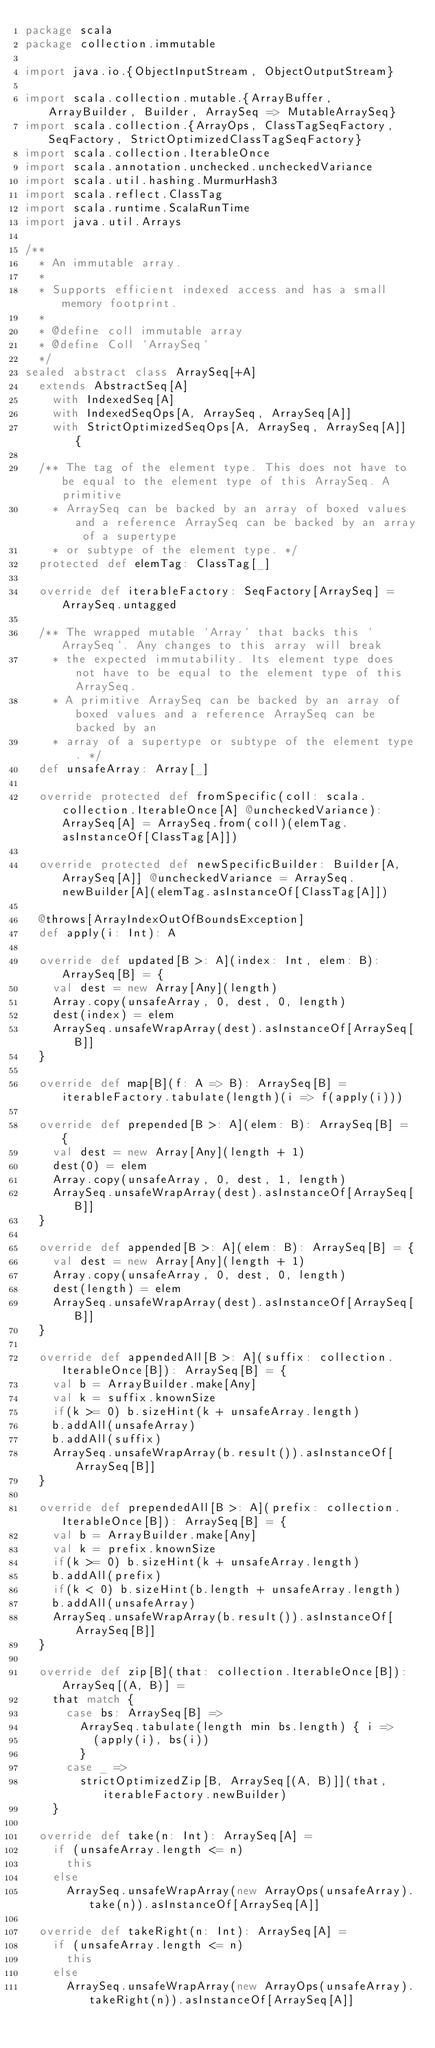Convert code to text. <code><loc_0><loc_0><loc_500><loc_500><_Scala_>package scala
package collection.immutable

import java.io.{ObjectInputStream, ObjectOutputStream}

import scala.collection.mutable.{ArrayBuffer, ArrayBuilder, Builder, ArraySeq => MutableArraySeq}
import scala.collection.{ArrayOps, ClassTagSeqFactory, SeqFactory, StrictOptimizedClassTagSeqFactory}
import scala.collection.IterableOnce
import scala.annotation.unchecked.uncheckedVariance
import scala.util.hashing.MurmurHash3
import scala.reflect.ClassTag
import scala.runtime.ScalaRunTime
import java.util.Arrays

/**
  * An immutable array.
  *
  * Supports efficient indexed access and has a small memory footprint.
  *
  * @define coll immutable array
  * @define Coll `ArraySeq`
  */
sealed abstract class ArraySeq[+A]
  extends AbstractSeq[A]
    with IndexedSeq[A]
    with IndexedSeqOps[A, ArraySeq, ArraySeq[A]]
    with StrictOptimizedSeqOps[A, ArraySeq, ArraySeq[A]] {

  /** The tag of the element type. This does not have to be equal to the element type of this ArraySeq. A primitive
    * ArraySeq can be backed by an array of boxed values and a reference ArraySeq can be backed by an array of a supertype
    * or subtype of the element type. */
  protected def elemTag: ClassTag[_]

  override def iterableFactory: SeqFactory[ArraySeq] = ArraySeq.untagged

  /** The wrapped mutable `Array` that backs this `ArraySeq`. Any changes to this array will break
    * the expected immutability. Its element type does not have to be equal to the element type of this ArraySeq.
    * A primitive ArraySeq can be backed by an array of boxed values and a reference ArraySeq can be backed by an
    * array of a supertype or subtype of the element type. */
  def unsafeArray: Array[_]

  override protected def fromSpecific(coll: scala.collection.IterableOnce[A] @uncheckedVariance): ArraySeq[A] = ArraySeq.from(coll)(elemTag.asInstanceOf[ClassTag[A]])

  override protected def newSpecificBuilder: Builder[A, ArraySeq[A]] @uncheckedVariance = ArraySeq.newBuilder[A](elemTag.asInstanceOf[ClassTag[A]])

  @throws[ArrayIndexOutOfBoundsException]
  def apply(i: Int): A

  override def updated[B >: A](index: Int, elem: B): ArraySeq[B] = {
    val dest = new Array[Any](length)
    Array.copy(unsafeArray, 0, dest, 0, length)
    dest(index) = elem
    ArraySeq.unsafeWrapArray(dest).asInstanceOf[ArraySeq[B]]
  }

  override def map[B](f: A => B): ArraySeq[B] = iterableFactory.tabulate(length)(i => f(apply(i)))

  override def prepended[B >: A](elem: B): ArraySeq[B] = {
    val dest = new Array[Any](length + 1)
    dest(0) = elem
    Array.copy(unsafeArray, 0, dest, 1, length)
    ArraySeq.unsafeWrapArray(dest).asInstanceOf[ArraySeq[B]]
  }

  override def appended[B >: A](elem: B): ArraySeq[B] = {
    val dest = new Array[Any](length + 1)
    Array.copy(unsafeArray, 0, dest, 0, length)
    dest(length) = elem
    ArraySeq.unsafeWrapArray(dest).asInstanceOf[ArraySeq[B]]
  }

  override def appendedAll[B >: A](suffix: collection.IterableOnce[B]): ArraySeq[B] = {
    val b = ArrayBuilder.make[Any]
    val k = suffix.knownSize
    if(k >= 0) b.sizeHint(k + unsafeArray.length)
    b.addAll(unsafeArray)
    b.addAll(suffix)
    ArraySeq.unsafeWrapArray(b.result()).asInstanceOf[ArraySeq[B]]
  }

  override def prependedAll[B >: A](prefix: collection.IterableOnce[B]): ArraySeq[B] = {
    val b = ArrayBuilder.make[Any]
    val k = prefix.knownSize
    if(k >= 0) b.sizeHint(k + unsafeArray.length)
    b.addAll(prefix)
    if(k < 0) b.sizeHint(b.length + unsafeArray.length)
    b.addAll(unsafeArray)
    ArraySeq.unsafeWrapArray(b.result()).asInstanceOf[ArraySeq[B]]
  }

  override def zip[B](that: collection.IterableOnce[B]): ArraySeq[(A, B)] =
    that match {
      case bs: ArraySeq[B] =>
        ArraySeq.tabulate(length min bs.length) { i =>
          (apply(i), bs(i))
        }
      case _ =>
        strictOptimizedZip[B, ArraySeq[(A, B)]](that, iterableFactory.newBuilder)
    }

  override def take(n: Int): ArraySeq[A] =
    if (unsafeArray.length <= n)
      this
    else
      ArraySeq.unsafeWrapArray(new ArrayOps(unsafeArray).take(n)).asInstanceOf[ArraySeq[A]]

  override def takeRight(n: Int): ArraySeq[A] =
    if (unsafeArray.length <= n)
      this
    else
      ArraySeq.unsafeWrapArray(new ArrayOps(unsafeArray).takeRight(n)).asInstanceOf[ArraySeq[A]]
</code> 